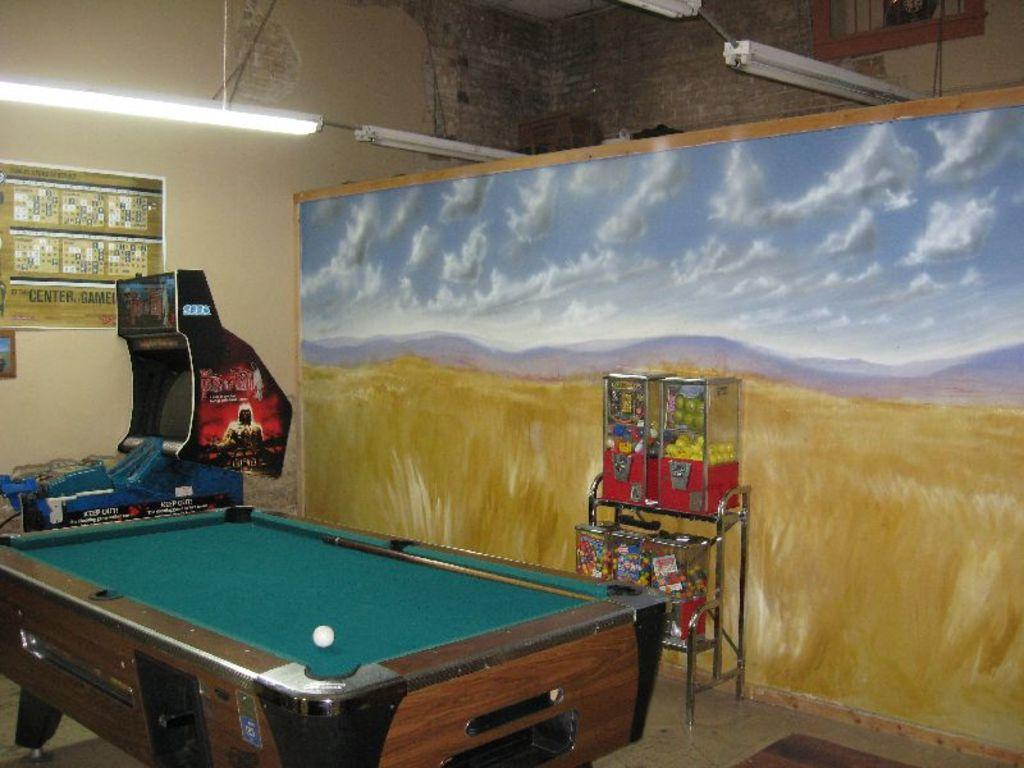What type of table is in the image? There is a tennis table in the image. What is on the table? There is a ball on the table. Can you describe the lighting in the image? There is a light visible in the image. What can be seen in the background of the image? There is a machine, a screen, and a sign board in the background. What objects are around the table? There are objects around the table. What type of oatmeal is being served in the garden in the image? There is no oatmeal or garden present in the image. How many boats can be seen sailing in the background of the image? There are no boats visible in the image. 